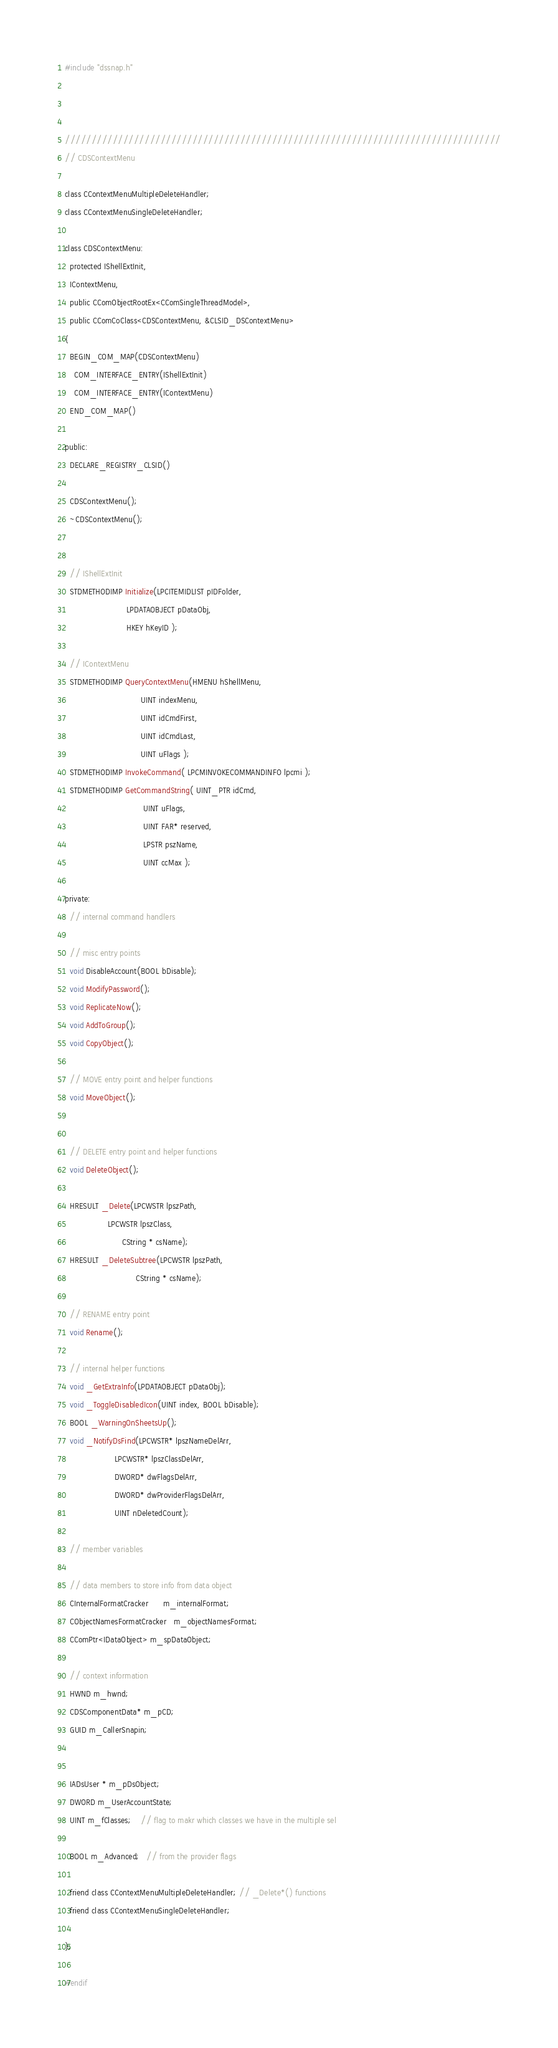<code> <loc_0><loc_0><loc_500><loc_500><_C_>

#include "dssnap.h"



//////////////////////////////////////////////////////////////////////////////////
// CDSContextMenu

class CContextMenuMultipleDeleteHandler;
class CContextMenuSingleDeleteHandler;

class CDSContextMenu:
  protected IShellExtInit,
  IContextMenu,
  public CComObjectRootEx<CComSingleThreadModel>,
  public CComCoClass<CDSContextMenu, &CLSID_DSContextMenu>
{
  BEGIN_COM_MAP(CDSContextMenu)
    COM_INTERFACE_ENTRY(IShellExtInit)
    COM_INTERFACE_ENTRY(IContextMenu)
  END_COM_MAP()

public:
  DECLARE_REGISTRY_CLSID()

  CDSContextMenu();
  ~CDSContextMenu();


  // IShellExtInit
  STDMETHODIMP Initialize(LPCITEMIDLIST pIDFolder, 
                          LPDATAOBJECT pDataObj, 
                          HKEY hKeyID );
  
  // IContextMenu
  STDMETHODIMP QueryContextMenu(HMENU hShellMenu,
                                UINT indexMenu,
                                UINT idCmdFirst, 
                                UINT idCmdLast,
                                UINT uFlags );
  STDMETHODIMP InvokeCommand( LPCMINVOKECOMMANDINFO lpcmi );
  STDMETHODIMP GetCommandString( UINT_PTR idCmd,
                                 UINT uFlags,
                                 UINT FAR* reserved,
                                 LPSTR pszName, 
                                 UINT ccMax );

private:  
  // internal command handlers

  // misc entry points
  void DisableAccount(BOOL bDisable);
  void ModifyPassword();
  void ReplicateNow();
  void AddToGroup();
  void CopyObject();

  // MOVE entry point and helper functions
  void MoveObject();


  // DELETE entry point and helper functions
  void DeleteObject();

  HRESULT _Delete(LPCWSTR lpszPath,
                  LPCWSTR lpszClass,
                        CString * csName);
  HRESULT _DeleteSubtree(LPCWSTR lpszPath,
                              CString * csName);

  // RENAME entry point
  void Rename();

  // internal helper functions
  void _GetExtraInfo(LPDATAOBJECT pDataObj);
  void _ToggleDisabledIcon(UINT index, BOOL bDisable);
  BOOL _WarningOnSheetsUp();
  void _NotifyDsFind(LPCWSTR* lpszNameDelArr, 
                     LPCWSTR* lpszClassDelArr, 
                     DWORD* dwFlagsDelArr, 
                     DWORD* dwProviderFlagsDelArr, 
                     UINT nDeletedCount);

  // member variables

  // data members to store info from data object
  CInternalFormatCracker      m_internalFormat;
  CObjectNamesFormatCracker   m_objectNamesFormat;
  CComPtr<IDataObject> m_spDataObject;

  // context information
  HWND m_hwnd;
  CDSComponentData* m_pCD;  
  GUID m_CallerSnapin;
  
 
  IADsUser * m_pDsObject;
  DWORD m_UserAccountState;
  UINT m_fClasses;    // flag to makr which classes we have in the multiple sel

  BOOL m_Advanced;   // from the provider flags
  
  friend class CContextMenuMultipleDeleteHandler; // _Delete*() functions
  friend class CContextMenuSingleDeleteHandler;

};

#endif
</code> 